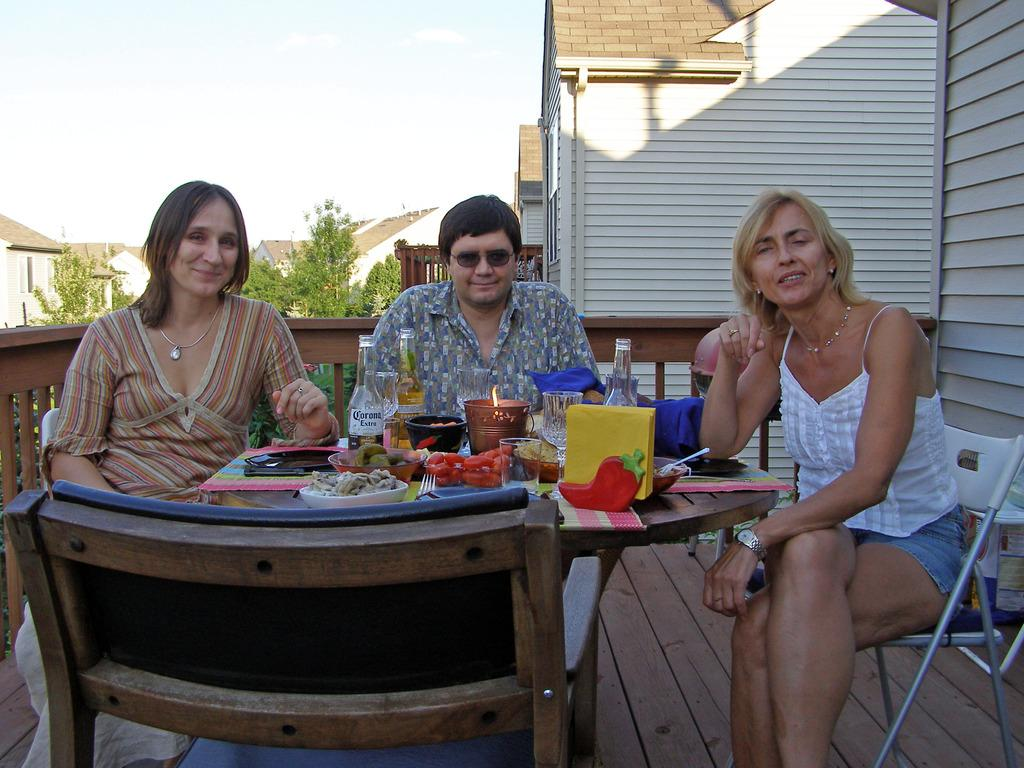How many people are sitting at the table in the image? There are 3 people sitting on chairs at the table. What is on the table with the people? There are bottles, food items, and plates on the table. What can be seen in the background of the image? Buildings, trees, and the sky are visible in the background. What type of spy equipment can be seen on the table in the image? There is no spy equipment present on the table in the image. Is there a meeting taking place in the image? The image does not provide any information about a meeting or any related activities. 